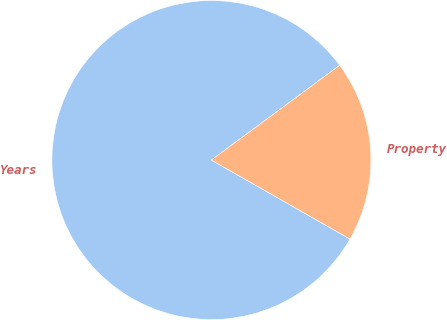<chart> <loc_0><loc_0><loc_500><loc_500><pie_chart><fcel>Years<fcel>Property<nl><fcel>81.63%<fcel>18.37%<nl></chart> 